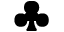<formula> <loc_0><loc_0><loc_500><loc_500>\clubsuit</formula> 